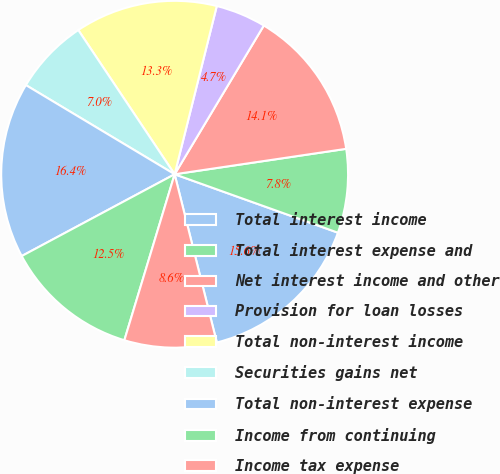<chart> <loc_0><loc_0><loc_500><loc_500><pie_chart><fcel>Total interest income<fcel>Total interest expense and<fcel>Net interest income and other<fcel>Provision for loan losses<fcel>Total non-interest income<fcel>Securities gains net<fcel>Total non-interest expense<fcel>Income from continuing<fcel>Income tax expense<nl><fcel>15.62%<fcel>7.81%<fcel>14.06%<fcel>4.69%<fcel>13.28%<fcel>7.03%<fcel>16.41%<fcel>12.5%<fcel>8.59%<nl></chart> 